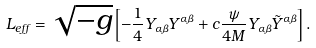<formula> <loc_0><loc_0><loc_500><loc_500>L _ { e f f } = \sqrt { - g } \left [ - \frac { 1 } { 4 } Y _ { \alpha \beta } Y ^ { \alpha \beta } + c \frac { \psi } { 4 M } Y _ { \alpha \beta } \tilde { Y } ^ { \alpha \beta } \right ] .</formula> 